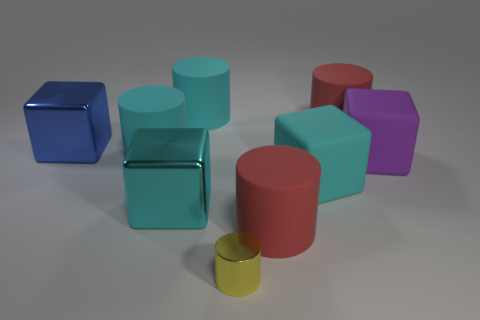Is the number of large red blocks greater than the number of big cyan matte cylinders?
Your answer should be very brief. No. There is a big cyan matte object in front of the purple thing; is it the same shape as the small object?
Provide a short and direct response. No. What number of rubber objects are either cyan cubes or purple balls?
Offer a terse response. 1. Is there a big gray thing made of the same material as the small object?
Your answer should be compact. No. What is the large purple thing made of?
Your response must be concise. Rubber. There is a red rubber thing that is behind the large red cylinder that is in front of the cyan thing to the right of the small yellow object; what shape is it?
Your response must be concise. Cylinder. Are there more tiny cylinders on the left side of the cyan metallic block than tiny things?
Offer a terse response. No. There is a blue thing; does it have the same shape as the large cyan matte object right of the small yellow cylinder?
Ensure brevity in your answer.  Yes. There is a large cube left of the metal cube on the right side of the blue object; what number of big things are right of it?
Offer a terse response. 7. What is the color of the other rubber cube that is the same size as the purple block?
Ensure brevity in your answer.  Cyan. 